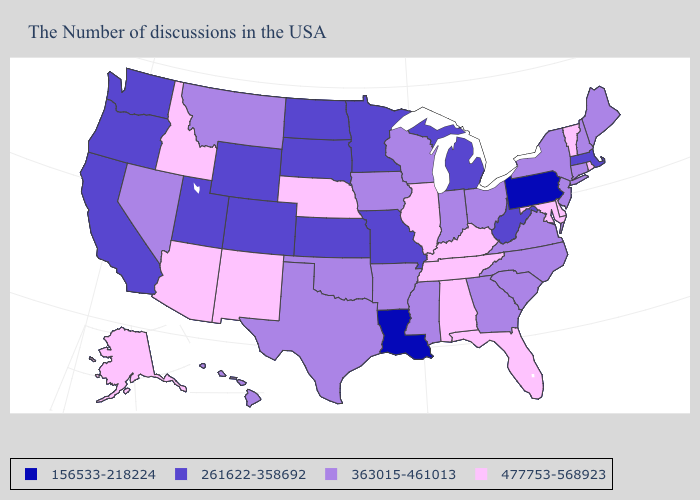Does Connecticut have the same value as Hawaii?
Be succinct. Yes. Among the states that border Maryland , does West Virginia have the lowest value?
Write a very short answer. No. Which states have the highest value in the USA?
Answer briefly. Rhode Island, Vermont, Delaware, Maryland, Florida, Kentucky, Alabama, Tennessee, Illinois, Nebraska, New Mexico, Arizona, Idaho, Alaska. Which states hav the highest value in the MidWest?
Short answer required. Illinois, Nebraska. Name the states that have a value in the range 156533-218224?
Write a very short answer. Pennsylvania, Louisiana. Among the states that border Maryland , does Pennsylvania have the lowest value?
Answer briefly. Yes. Name the states that have a value in the range 261622-358692?
Short answer required. Massachusetts, West Virginia, Michigan, Missouri, Minnesota, Kansas, South Dakota, North Dakota, Wyoming, Colorado, Utah, California, Washington, Oregon. Does the first symbol in the legend represent the smallest category?
Quick response, please. Yes. What is the value of Georgia?
Write a very short answer. 363015-461013. What is the lowest value in states that border Tennessee?
Write a very short answer. 261622-358692. Does Vermont have the highest value in the USA?
Write a very short answer. Yes. Among the states that border Virginia , does Kentucky have the highest value?
Quick response, please. Yes. Does the first symbol in the legend represent the smallest category?
Keep it brief. Yes. Name the states that have a value in the range 156533-218224?
Be succinct. Pennsylvania, Louisiana. What is the value of Michigan?
Answer briefly. 261622-358692. 